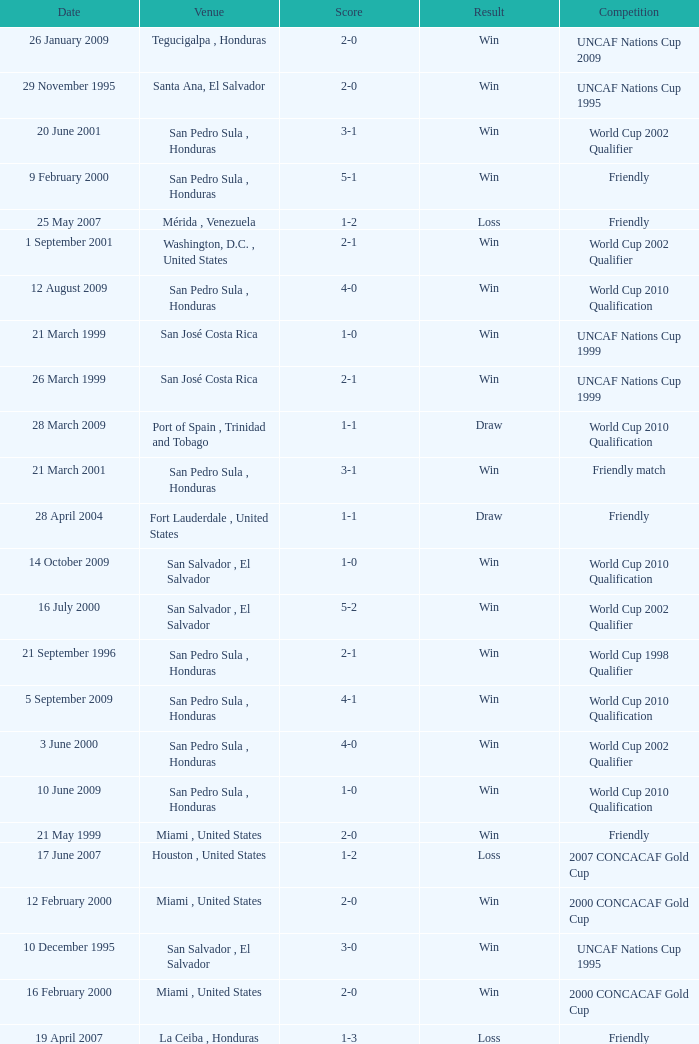Name the score for 7 may 2000 3-1. 